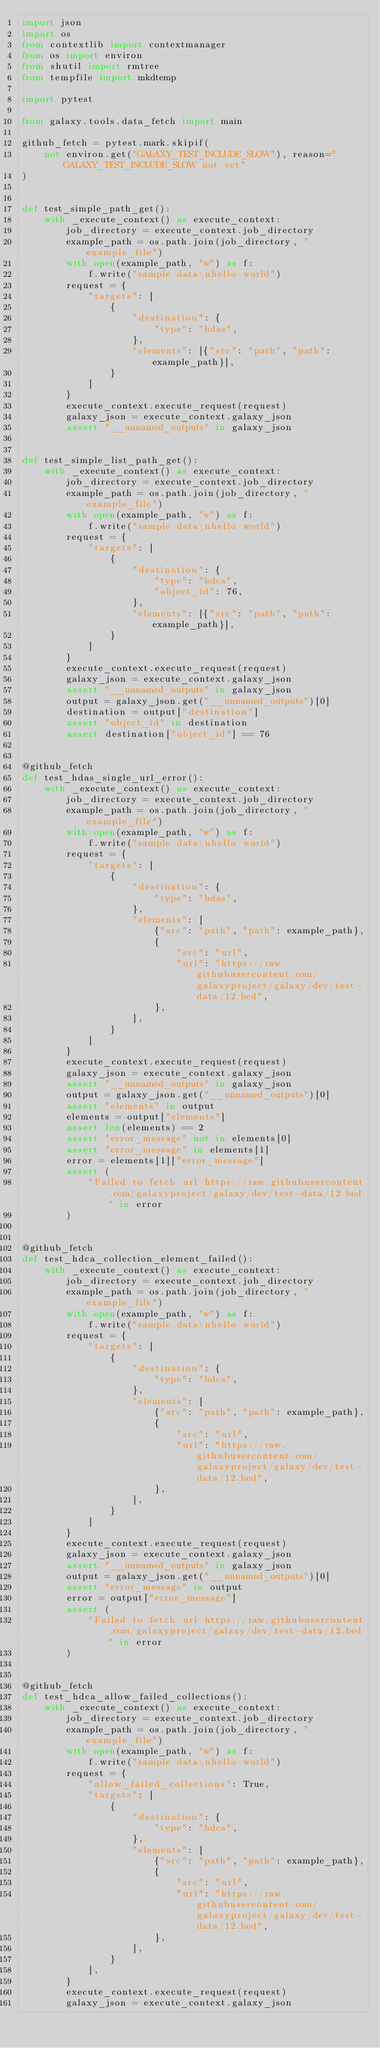Convert code to text. <code><loc_0><loc_0><loc_500><loc_500><_Python_>import json
import os
from contextlib import contextmanager
from os import environ
from shutil import rmtree
from tempfile import mkdtemp

import pytest

from galaxy.tools.data_fetch import main

github_fetch = pytest.mark.skipif(
    not environ.get("GALAXY_TEST_INCLUDE_SLOW"), reason="GALAXY_TEST_INCLUDE_SLOW not set"
)


def test_simple_path_get():
    with _execute_context() as execute_context:
        job_directory = execute_context.job_directory
        example_path = os.path.join(job_directory, "example_file")
        with open(example_path, "w") as f:
            f.write("sample data\nhello world")
        request = {
            "targets": [
                {
                    "destination": {
                        "type": "hdas",
                    },
                    "elements": [{"src": "path", "path": example_path}],
                }
            ]
        }
        execute_context.execute_request(request)
        galaxy_json = execute_context.galaxy_json
        assert "__unnamed_outputs" in galaxy_json


def test_simple_list_path_get():
    with _execute_context() as execute_context:
        job_directory = execute_context.job_directory
        example_path = os.path.join(job_directory, "example_file")
        with open(example_path, "w") as f:
            f.write("sample data\nhello world")
        request = {
            "targets": [
                {
                    "destination": {
                        "type": "hdca",
                        "object_id": 76,
                    },
                    "elements": [{"src": "path", "path": example_path}],
                }
            ]
        }
        execute_context.execute_request(request)
        galaxy_json = execute_context.galaxy_json
        assert "__unnamed_outputs" in galaxy_json
        output = galaxy_json.get("__unnamed_outputs")[0]
        destination = output["destination"]
        assert "object_id" in destination
        assert destination["object_id"] == 76


@github_fetch
def test_hdas_single_url_error():
    with _execute_context() as execute_context:
        job_directory = execute_context.job_directory
        example_path = os.path.join(job_directory, "example_file")
        with open(example_path, "w") as f:
            f.write("sample data\nhello world")
        request = {
            "targets": [
                {
                    "destination": {
                        "type": "hdas",
                    },
                    "elements": [
                        {"src": "path", "path": example_path},
                        {
                            "src": "url",
                            "url": "https://raw.githubusercontent.com/galaxyproject/galaxy/dev/test-data/12.bed",
                        },
                    ],
                }
            ]
        }
        execute_context.execute_request(request)
        galaxy_json = execute_context.galaxy_json
        assert "__unnamed_outputs" in galaxy_json
        output = galaxy_json.get("__unnamed_outputs")[0]
        assert "elements" in output
        elements = output["elements"]
        assert len(elements) == 2
        assert "error_message" not in elements[0]
        assert "error_message" in elements[1]
        error = elements[1]["error_message"]
        assert (
            "Failed to fetch url https://raw.githubusercontent.com/galaxyproject/galaxy/dev/test-data/12.bed" in error
        )


@github_fetch
def test_hdca_collection_element_failed():
    with _execute_context() as execute_context:
        job_directory = execute_context.job_directory
        example_path = os.path.join(job_directory, "example_file")
        with open(example_path, "w") as f:
            f.write("sample data\nhello world")
        request = {
            "targets": [
                {
                    "destination": {
                        "type": "hdca",
                    },
                    "elements": [
                        {"src": "path", "path": example_path},
                        {
                            "src": "url",
                            "url": "https://raw.githubusercontent.com/galaxyproject/galaxy/dev/test-data/12.bed",
                        },
                    ],
                }
            ]
        }
        execute_context.execute_request(request)
        galaxy_json = execute_context.galaxy_json
        assert "__unnamed_outputs" in galaxy_json
        output = galaxy_json.get("__unnamed_outputs")[0]
        assert "error_message" in output
        error = output["error_message"]
        assert (
            "Failed to fetch url https://raw.githubusercontent.com/galaxyproject/galaxy/dev/test-data/12.bed" in error
        )


@github_fetch
def test_hdca_allow_failed_collections():
    with _execute_context() as execute_context:
        job_directory = execute_context.job_directory
        example_path = os.path.join(job_directory, "example_file")
        with open(example_path, "w") as f:
            f.write("sample data\nhello world")
        request = {
            "allow_failed_collections": True,
            "targets": [
                {
                    "destination": {
                        "type": "hdca",
                    },
                    "elements": [
                        {"src": "path", "path": example_path},
                        {
                            "src": "url",
                            "url": "https://raw.githubusercontent.com/galaxyproject/galaxy/dev/test-data/12.bed",
                        },
                    ],
                }
            ],
        }
        execute_context.execute_request(request)
        galaxy_json = execute_context.galaxy_json</code> 